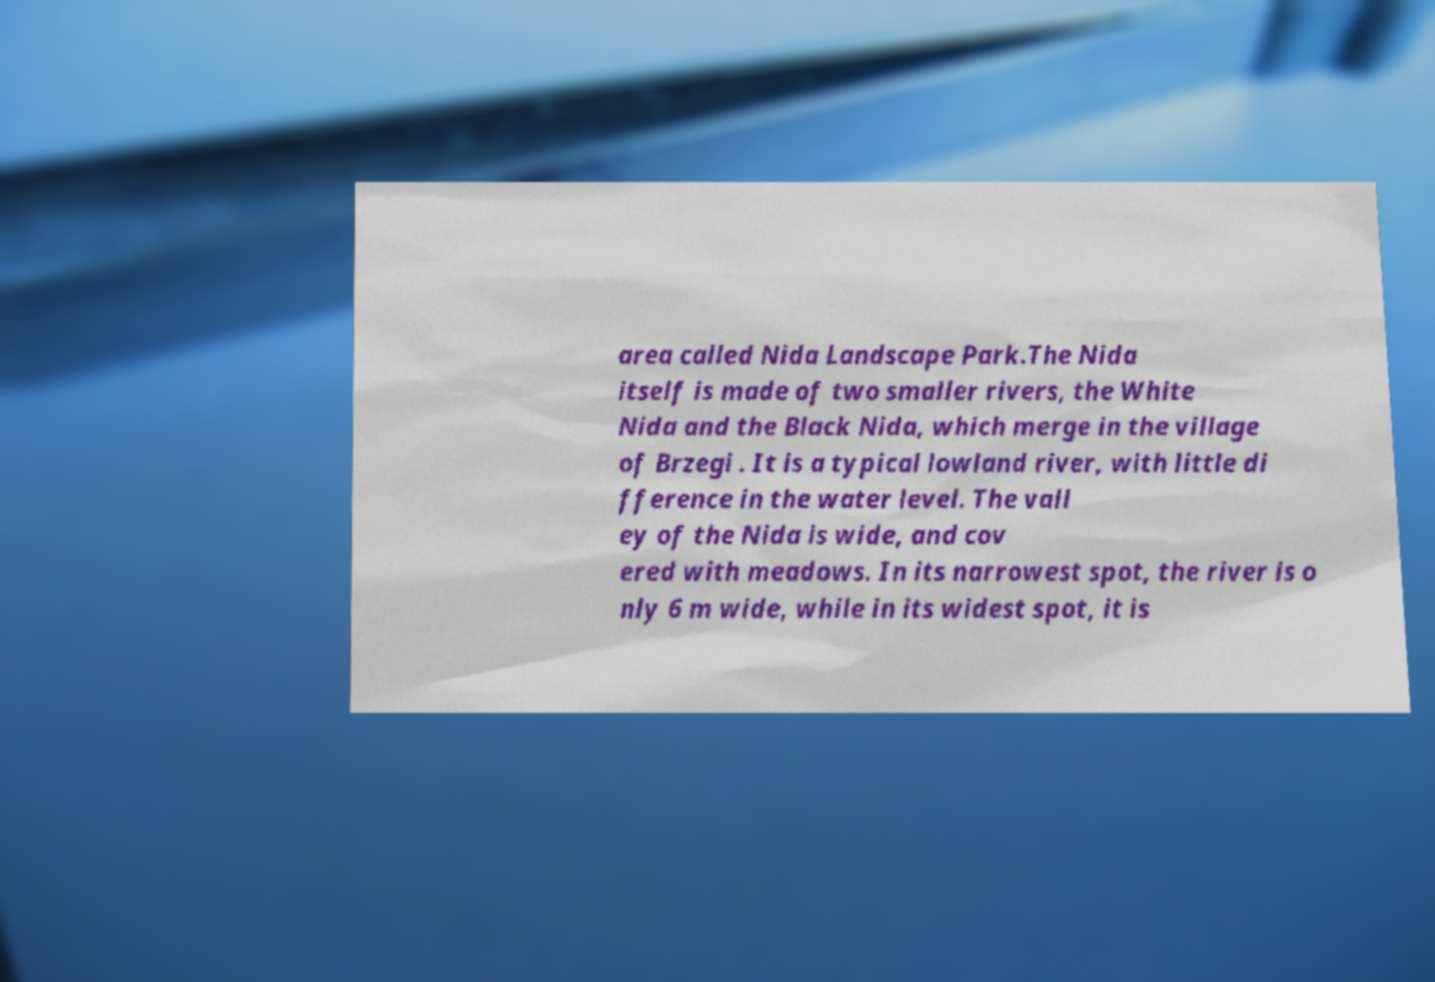Could you assist in decoding the text presented in this image and type it out clearly? area called Nida Landscape Park.The Nida itself is made of two smaller rivers, the White Nida and the Black Nida, which merge in the village of Brzegi . It is a typical lowland river, with little di fference in the water level. The vall ey of the Nida is wide, and cov ered with meadows. In its narrowest spot, the river is o nly 6 m wide, while in its widest spot, it is 